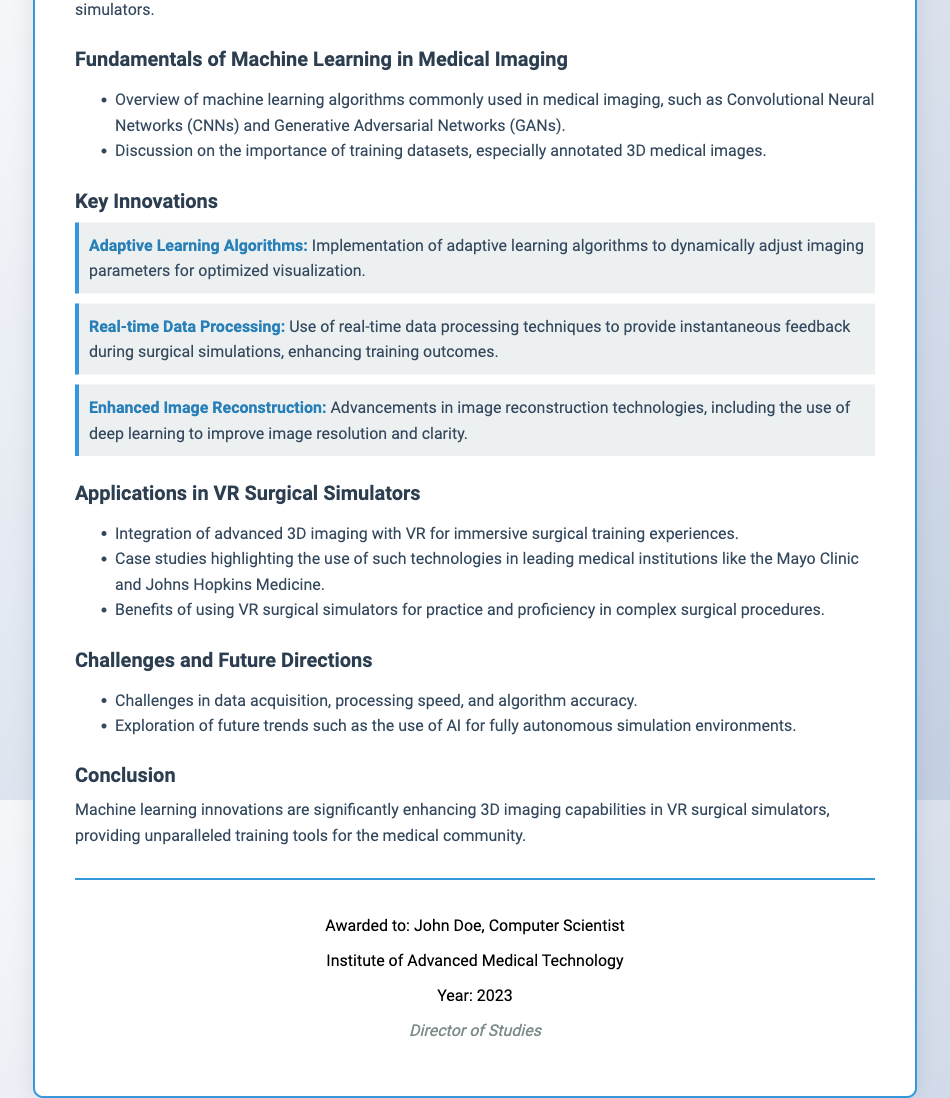What is the title of the diploma? The title is a key piece of information found prominently in the document, specifically in the header section.
Answer: Innovations in Machine Learning for Enhanced 3D Imaging in Virtual Reality Surgical Simulators Who is awarded the diploma? The name is stated towards the end of the document, in the footer section.
Answer: John Doe What year was the diploma awarded? This information is found in the footer section, specifically mentioning the year of the diploma issue.
Answer: 2023 What is one of the key innovations listed in the document? The innovation section lists multiple innovations; one example can be taken directly from the content.
Answer: Adaptive Learning Algorithms Which institution is mentioned in relation to the applications of VR surgical simulators? The document refers to notable institutions under the applications section, highlighting their role in this technological integration.
Answer: Mayo Clinic What is emphasized as a benefit of using VR surgical simulators? This is a specific benefit mentioned under the applications section, noting the advantages of these simulators.
Answer: Practice and proficiency in complex surgical procedures What does the conclusion state about machine learning innovations? The conclusion summarizes the overall impact of innovations mentioned throughout the document.
Answer: Significantly enhancing 3D imaging capabilities What is one challenge discussed in the document? The challenges and future directions section outlines several challenges encountered in the field.
Answer: Data acquisition 